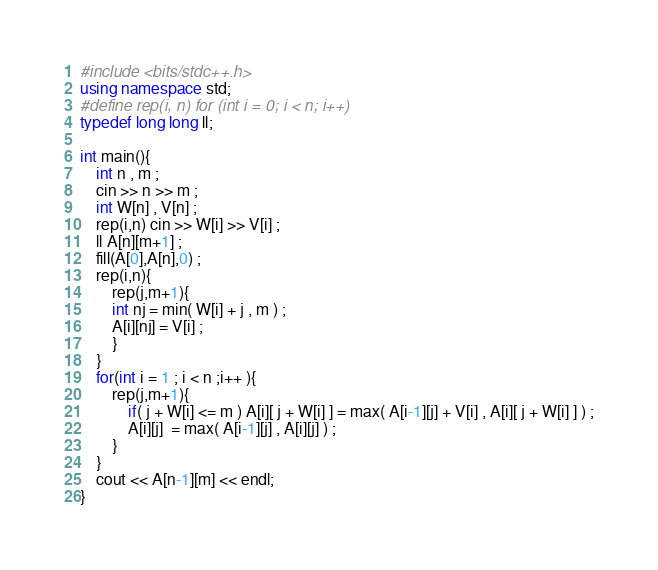Convert code to text. <code><loc_0><loc_0><loc_500><loc_500><_C++_>#include <bits/stdc++.h>
using namespace std;
#define rep(i, n) for (int i = 0; i < n; i++)
typedef long long ll;

int main(){
    int n , m ;
    cin >> n >> m ;
    int W[n] , V[n] ;
    rep(i,n) cin >> W[i] >> V[i] ;
    ll A[n][m+1] ;
    fill(A[0],A[n],0) ;
    rep(i,n){
        rep(j,m+1){
        int nj = min( W[i] + j , m ) ;
        A[i][nj] = V[i] ;
        }
    }
    for(int i = 1 ; i < n ;i++ ){
        rep(j,m+1){
            if( j + W[i] <= m ) A[i][ j + W[i] ] = max( A[i-1][j] + V[i] , A[i][ j + W[i] ] ) ;
            A[i][j]  = max( A[i-1][j] , A[i][j] ) ;
        }
    }
    cout << A[n-1][m] << endl;
}</code> 